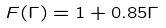<formula> <loc_0><loc_0><loc_500><loc_500>F ( \Gamma ) = 1 + 0 . 8 5 \Gamma</formula> 